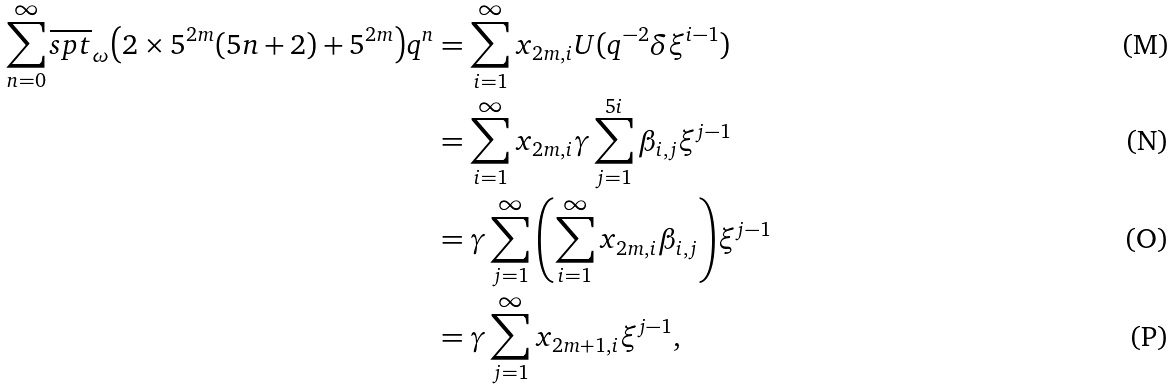Convert formula to latex. <formula><loc_0><loc_0><loc_500><loc_500>\sum _ { n = 0 } ^ { \infty } \overline { s p t } _ { \omega } { \left ( 2 \times 5 ^ { 2 m } ( 5 n + 2 ) + 5 ^ { 2 m } \right ) } q ^ { n } & = \sum _ { i = 1 } ^ { \infty } x _ { 2 m , i } U ( q ^ { - 2 } \delta \xi ^ { i - 1 } ) \\ & = \sum _ { i = 1 } ^ { \infty } x _ { 2 m , i } \gamma \sum _ { j = 1 } ^ { 5 i } \beta _ { i , j } \xi ^ { j - 1 } \\ & = \gamma \sum _ { j = 1 } ^ { \infty } { \left ( \sum _ { i = 1 } ^ { \infty } x _ { 2 m , i } \beta _ { i , j } \right ) } \xi ^ { j - 1 } \\ & = \gamma \sum _ { j = 1 } ^ { \infty } x _ { 2 m + 1 , i } \xi ^ { j - 1 } ,</formula> 